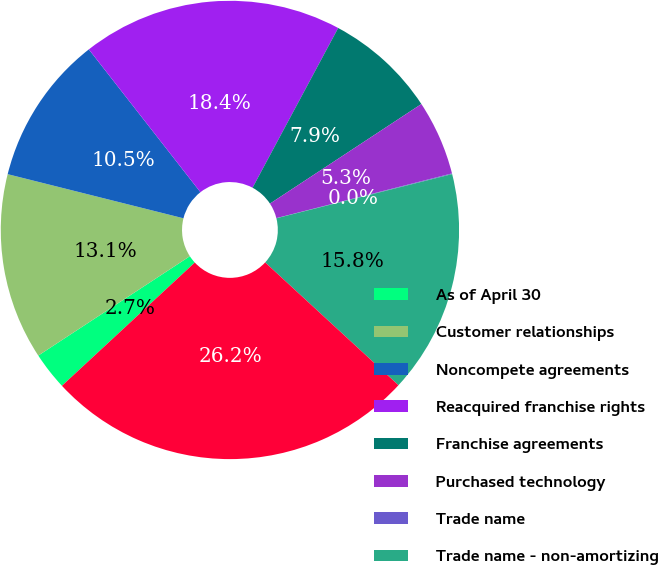Convert chart to OTSL. <chart><loc_0><loc_0><loc_500><loc_500><pie_chart><fcel>As of April 30<fcel>Customer relationships<fcel>Noncompete agreements<fcel>Reacquired franchise rights<fcel>Franchise agreements<fcel>Purchased technology<fcel>Trade name<fcel>Trade name - non-amortizing<fcel>Total intangible assets<nl><fcel>2.67%<fcel>13.15%<fcel>10.53%<fcel>18.39%<fcel>7.91%<fcel>5.29%<fcel>0.05%<fcel>15.77%<fcel>26.25%<nl></chart> 